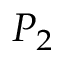<formula> <loc_0><loc_0><loc_500><loc_500>P _ { 2 }</formula> 